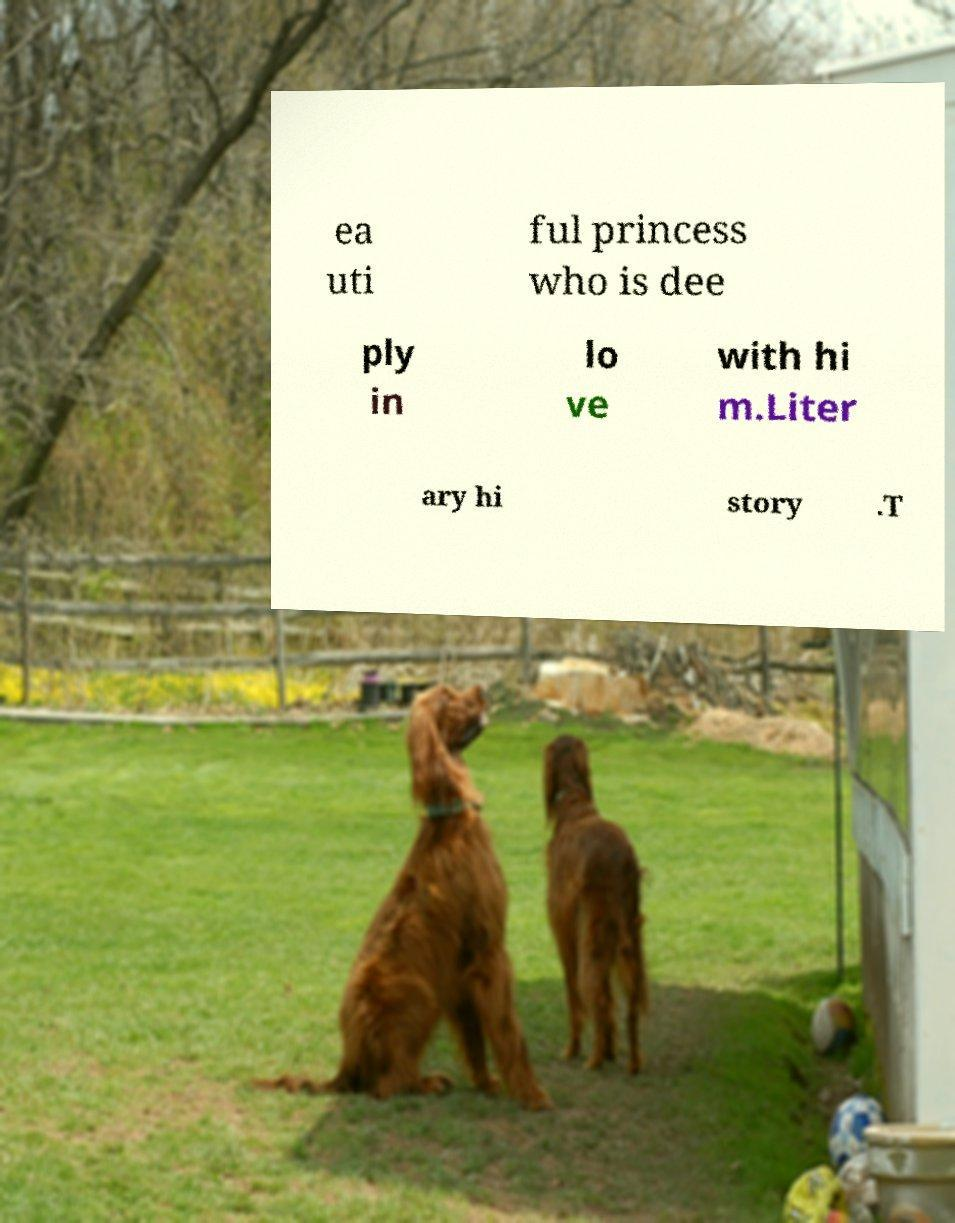What messages or text are displayed in this image? I need them in a readable, typed format. ea uti ful princess who is dee ply in lo ve with hi m.Liter ary hi story .T 